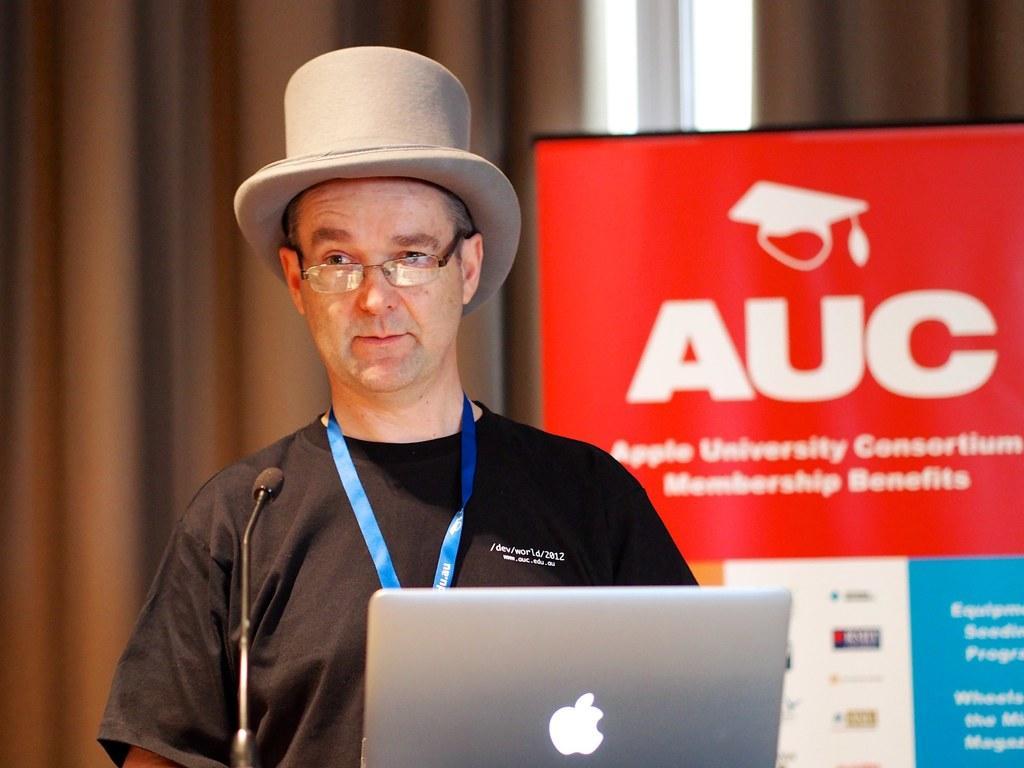Describe this image in one or two sentences. In this picture we can see a man, he wore a cap and spectacles, in front of him we can see a microphone and a laptop, in the background we can find a hoarding. 